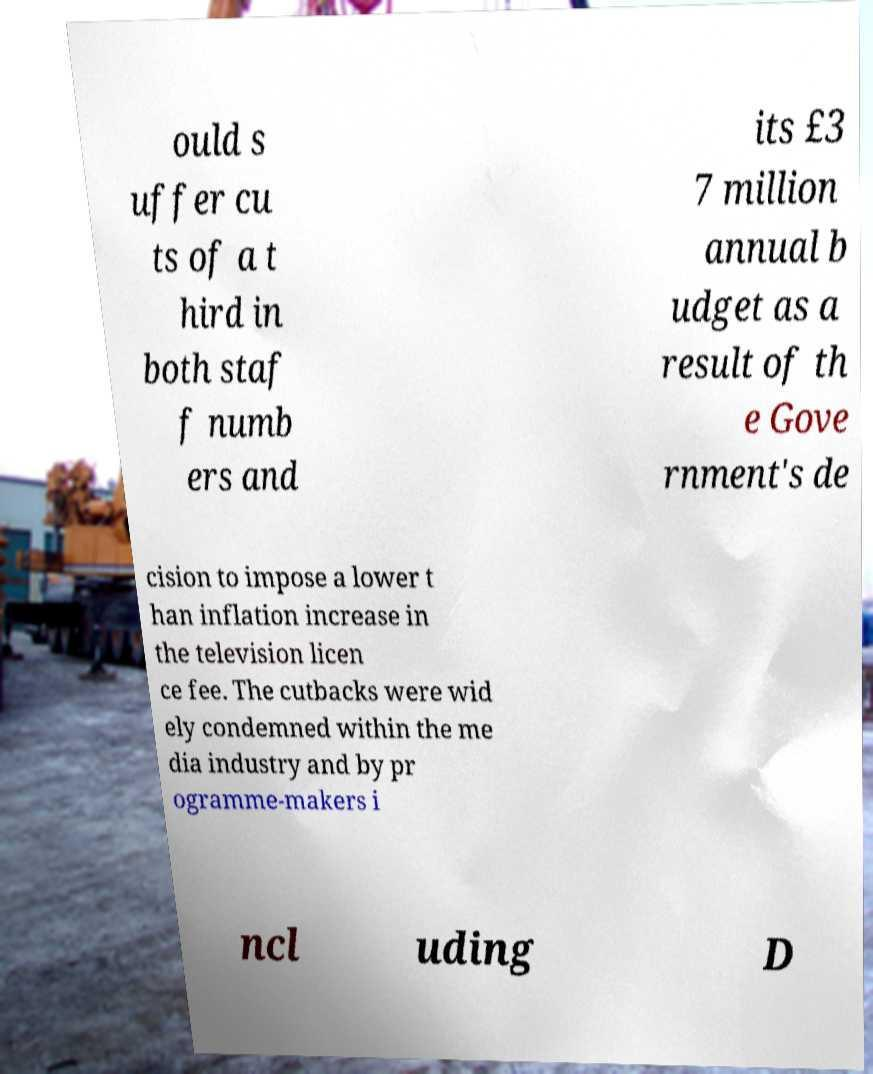There's text embedded in this image that I need extracted. Can you transcribe it verbatim? ould s uffer cu ts of a t hird in both staf f numb ers and its £3 7 million annual b udget as a result of th e Gove rnment's de cision to impose a lower t han inflation increase in the television licen ce fee. The cutbacks were wid ely condemned within the me dia industry and by pr ogramme-makers i ncl uding D 